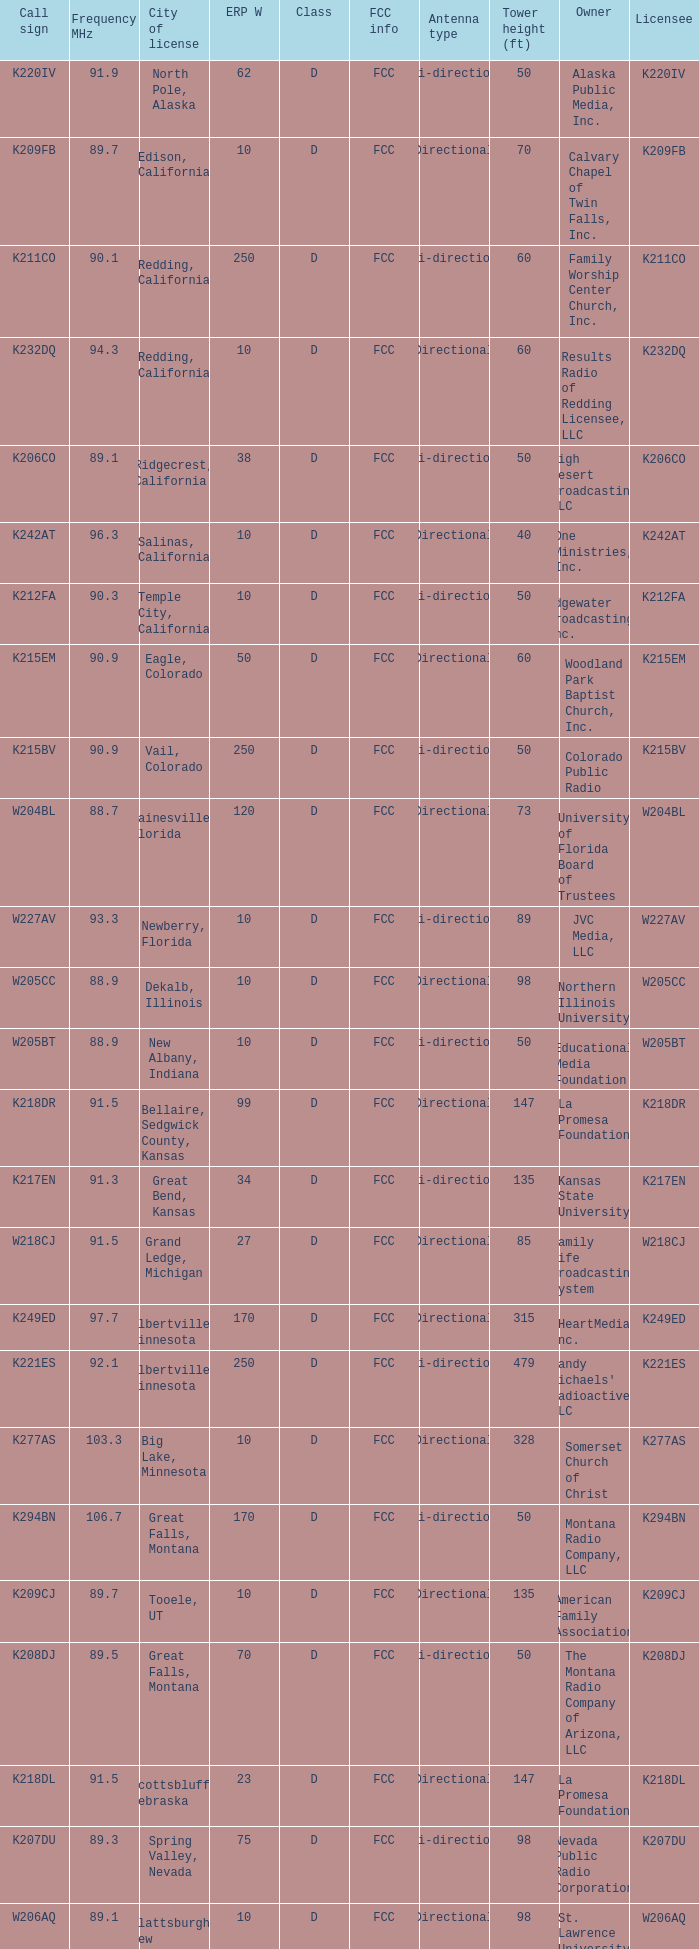What is the FCC info of the translator with an Irmo, South Carolina city license? FCC. 